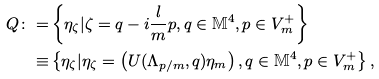Convert formula to latex. <formula><loc_0><loc_0><loc_500><loc_500>Q \colon = & \left \{ \eta _ { \zeta } | \zeta = q - i \frac { l } { m } p , q \in \mathbb { M } ^ { 4 } , p \in V _ { m } ^ { + } \right \} \\ \equiv & \left \{ \eta _ { \zeta } | \eta _ { \zeta } = \left ( U ( \Lambda _ { p / m } , q ) \eta _ { m } \right ) , q \in \mathbb { M } ^ { 4 } , p \in V _ { m } ^ { + } \right \} ,</formula> 